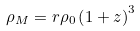<formula> <loc_0><loc_0><loc_500><loc_500>\rho _ { M } = r \rho _ { 0 } \left ( 1 + z \right ) ^ { 3 }</formula> 